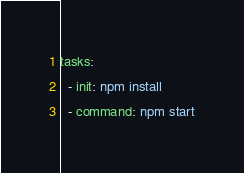<code> <loc_0><loc_0><loc_500><loc_500><_YAML_>tasks:
  - init: npm install
  - command: npm start
</code> 